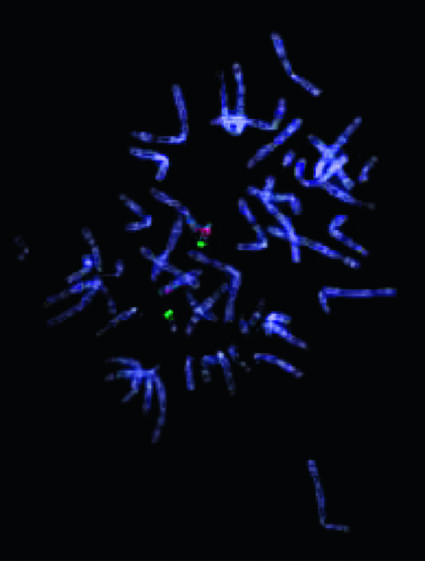how many chromosomes do not stain with the probe for 22q11 .2, indicating a microdeletion in this region?
Answer the question using a single word or phrase. One 